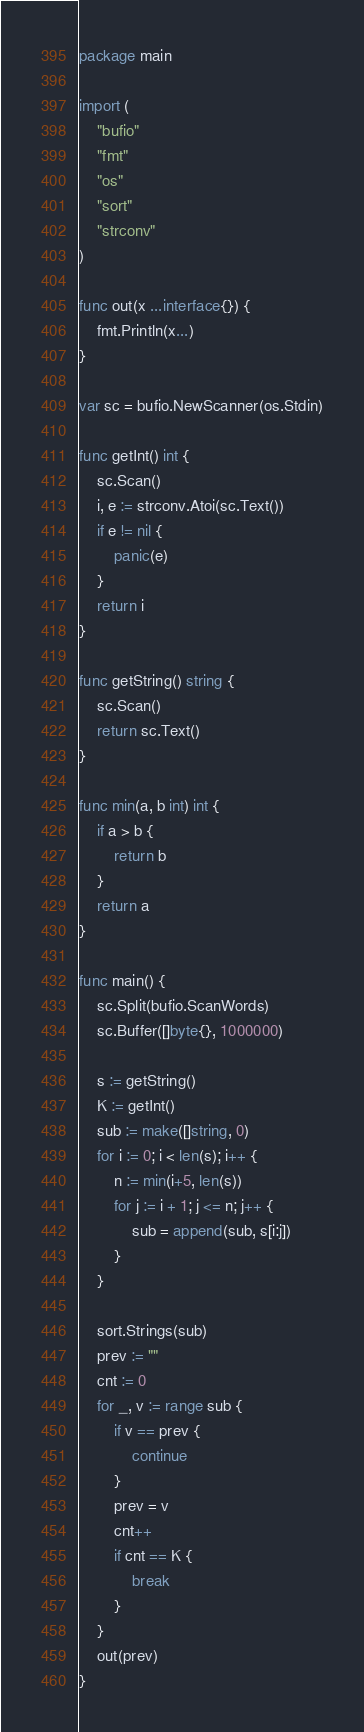<code> <loc_0><loc_0><loc_500><loc_500><_Go_>package main

import (
	"bufio"
	"fmt"
	"os"
	"sort"
	"strconv"
)

func out(x ...interface{}) {
	fmt.Println(x...)
}

var sc = bufio.NewScanner(os.Stdin)

func getInt() int {
	sc.Scan()
	i, e := strconv.Atoi(sc.Text())
	if e != nil {
		panic(e)
	}
	return i
}

func getString() string {
	sc.Scan()
	return sc.Text()
}

func min(a, b int) int {
	if a > b {
		return b
	}
	return a
}

func main() {
	sc.Split(bufio.ScanWords)
	sc.Buffer([]byte{}, 1000000)

	s := getString()
	K := getInt()
	sub := make([]string, 0)
	for i := 0; i < len(s); i++ {
		n := min(i+5, len(s))
		for j := i + 1; j <= n; j++ {
			sub = append(sub, s[i:j])
		}
	}

	sort.Strings(sub)
	prev := ""
	cnt := 0
	for _, v := range sub {
		if v == prev {
			continue
		}
		prev = v
		cnt++
		if cnt == K {
			break
		}
	}
	out(prev)
}
</code> 